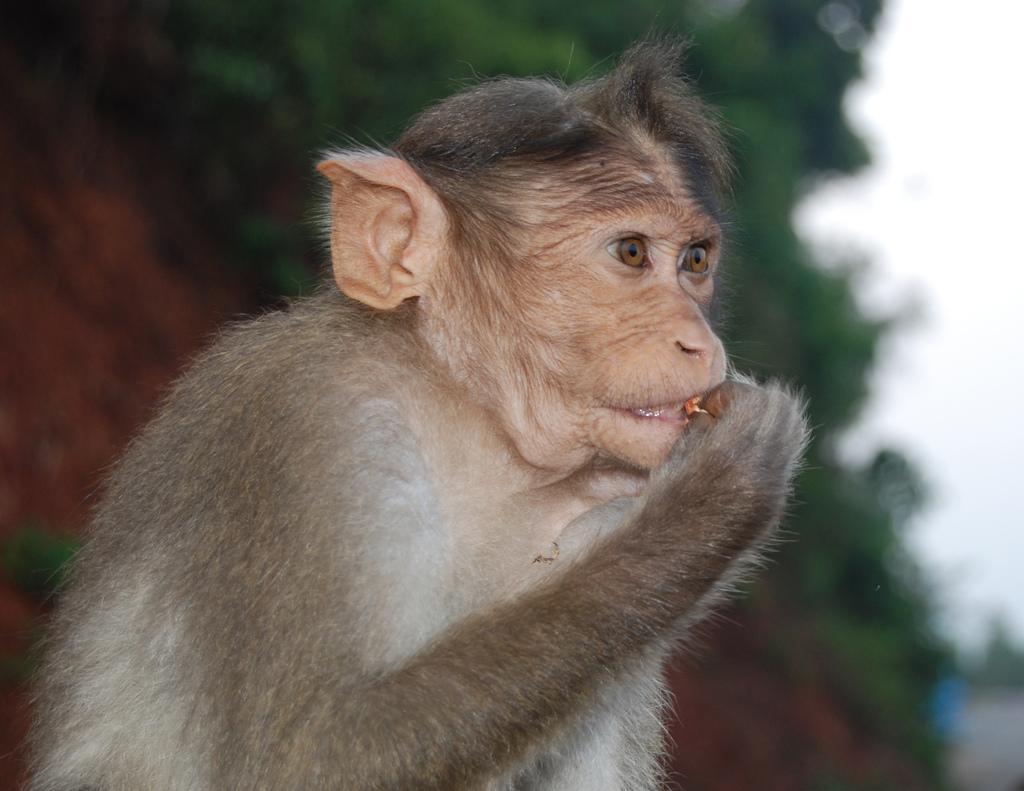In one or two sentences, can you explain what this image depicts? A monkey is eating something. The background is blurred. 